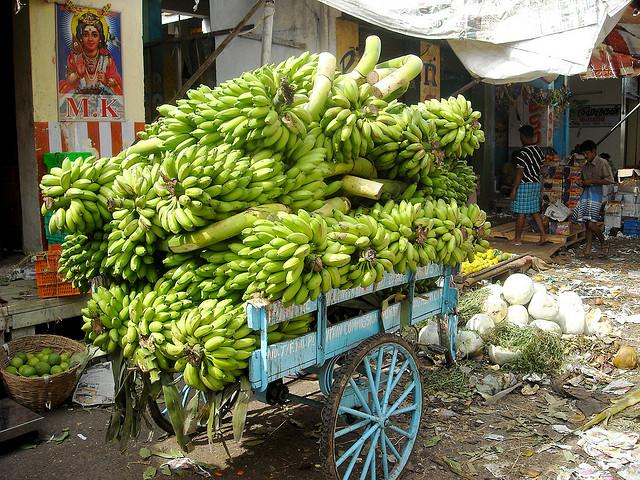What religion is common in this area? hinduism 